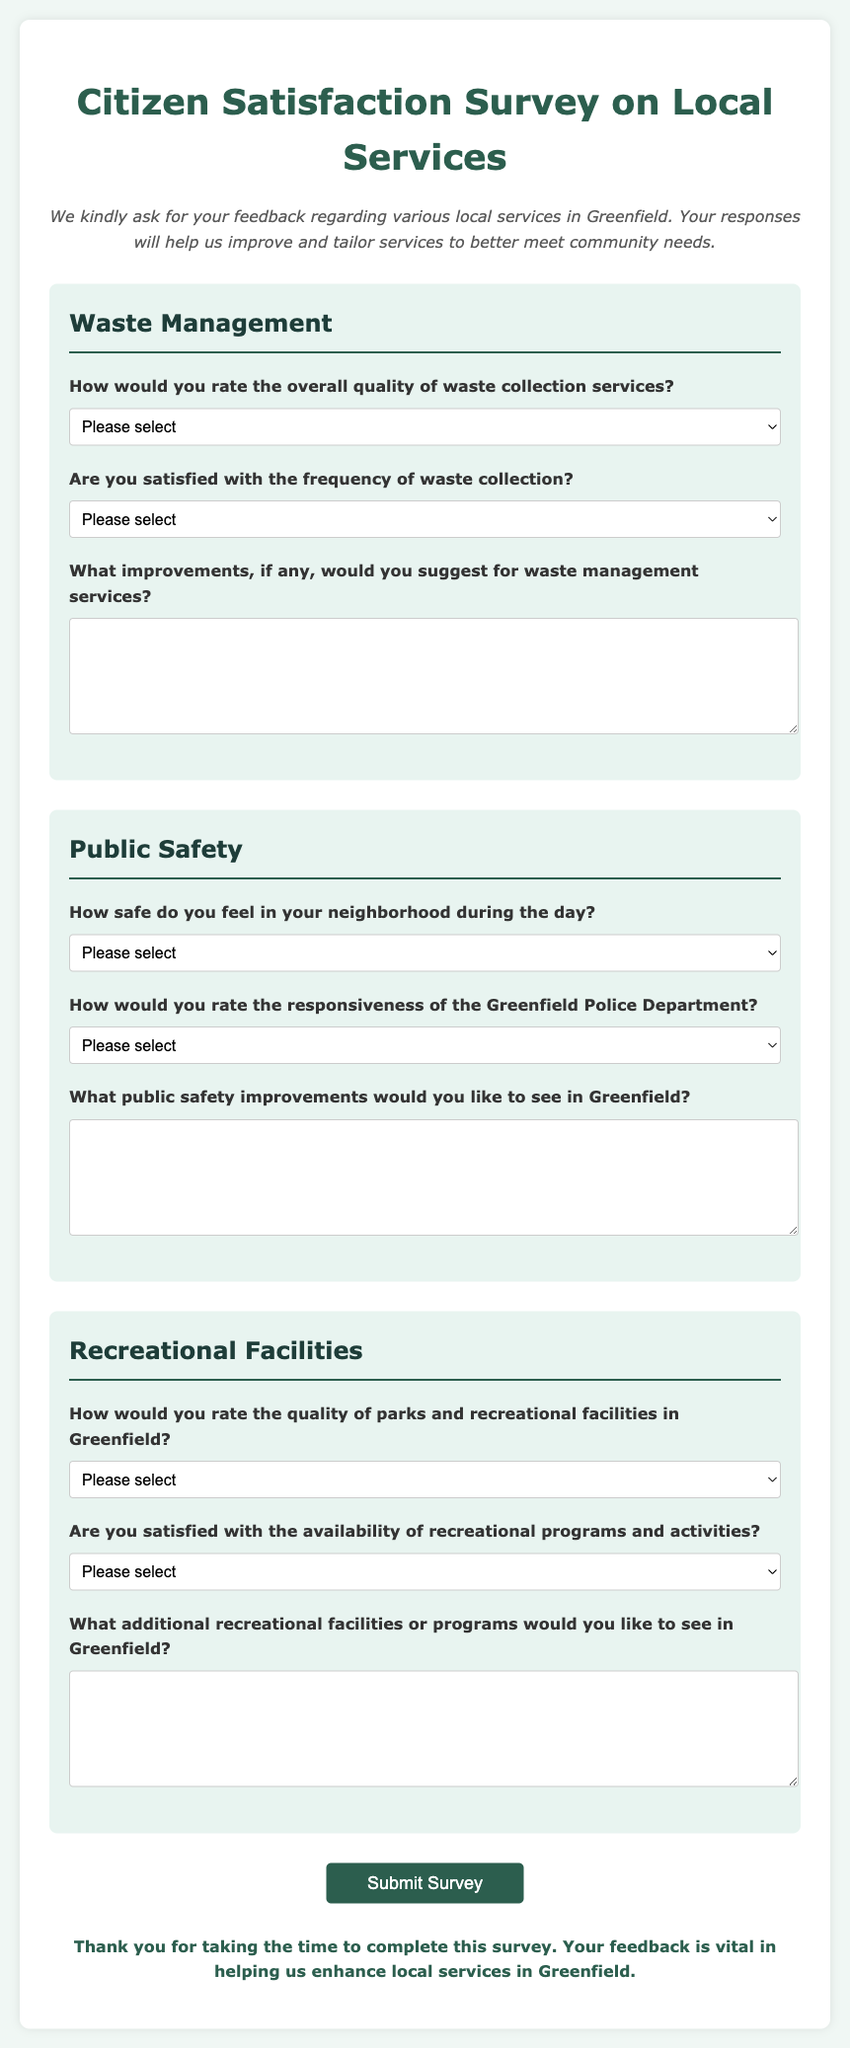What is the title of the survey? The title is prominently displayed at the top of the document, indicating the focus of the survey.
Answer: Citizen Satisfaction Survey on Local Services How many sections are there in the survey? The document is structured into three main sections, each covering a different aspect of local services.
Answer: 3 What type of feedback is encouraged in the waste management section? The document specifies that participants are asked for suggestions on improvements in waste management services.
Answer: Improvements What is the color used for the survey's heading? The color is indicated in the style section of the document, which specifies styling for the headings.
Answer: #2c5e4e Which department's responsiveness is evaluated in the public safety section? The survey includes a specific question related to the performance of a local agency that ensures public safety.
Answer: Greenfield Police Department What is the maximum number of options provided for the overall quality of waste collection services? The document lists the various options available for respondents to evaluate the service quality.
Answer: 4 What type of input is primarily requested in the recreational facilities section? The section encourages participants to provide suggestions regarding additional services or facilities.
Answer: Suggestions How are the respondents informed about the survey submission acknowledgment? The document includes a script that pops up an alert box upon form submission indicating appreciation for feedback.
Answer: Alert box message What feedback mechanism is mentioned for public safety improvements? The survey provides a space for respondents to suggest changes or enhancements related to local safety.
Answer: Safety improvements 